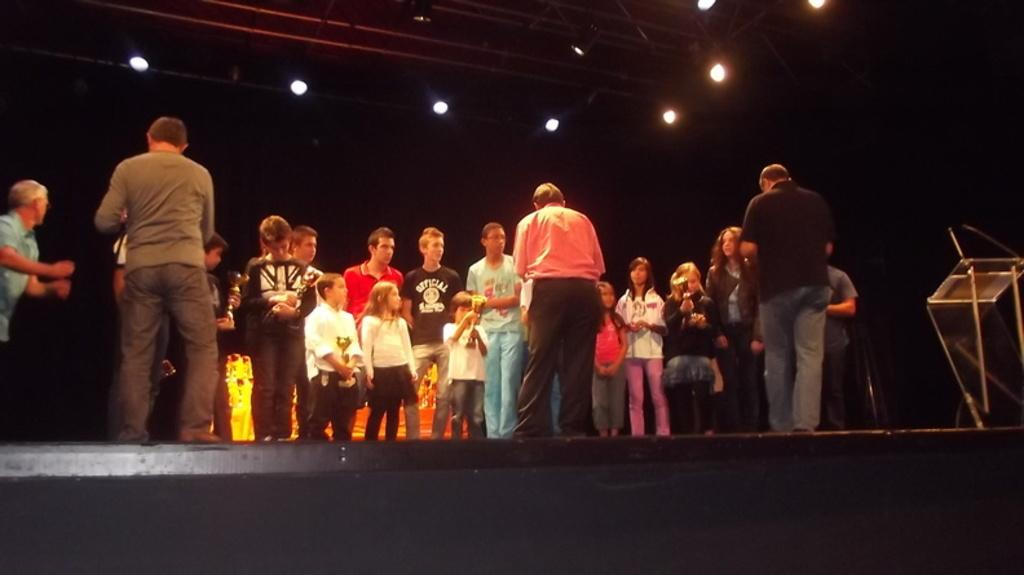What is happening in the image? There are people standing in the image. What object can be seen on the right side of the image? There is a podium on the right side of the image. What can be seen in the background of the image? There are lights and curtains in the background of the image. What type of ear is visible on the podium in the image? There is no ear visible on the podium or anywhere else in the image. 